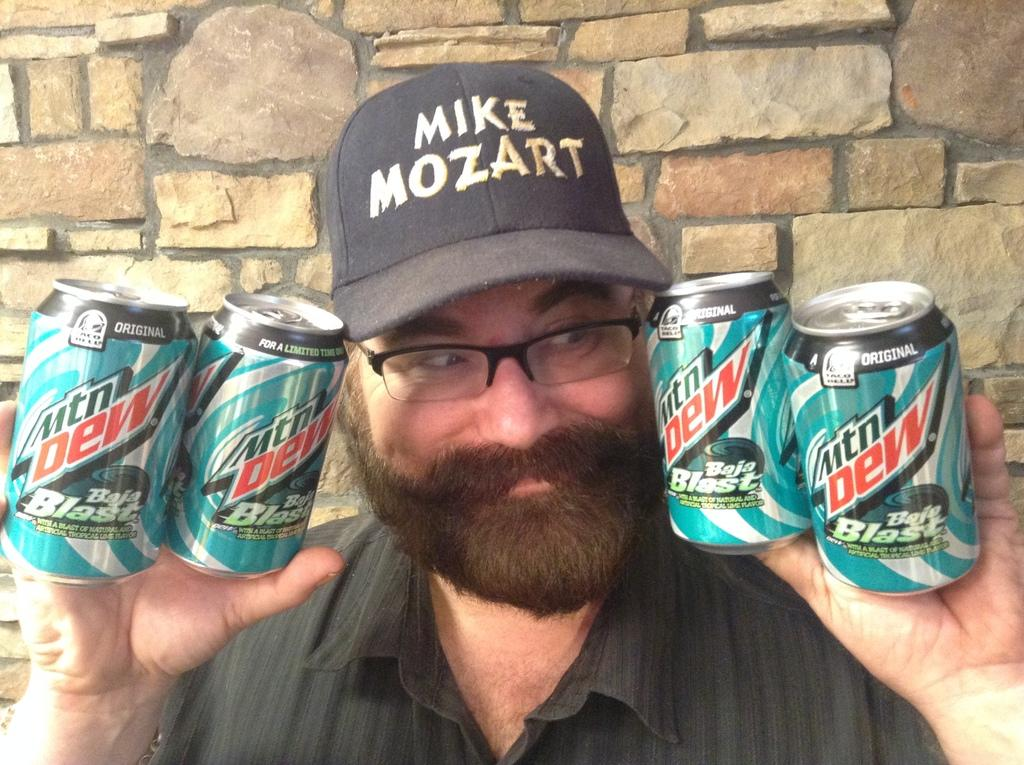<image>
Create a compact narrative representing the image presented. A man wearing a Mike Mozart hat holding four Mountain Dews. 